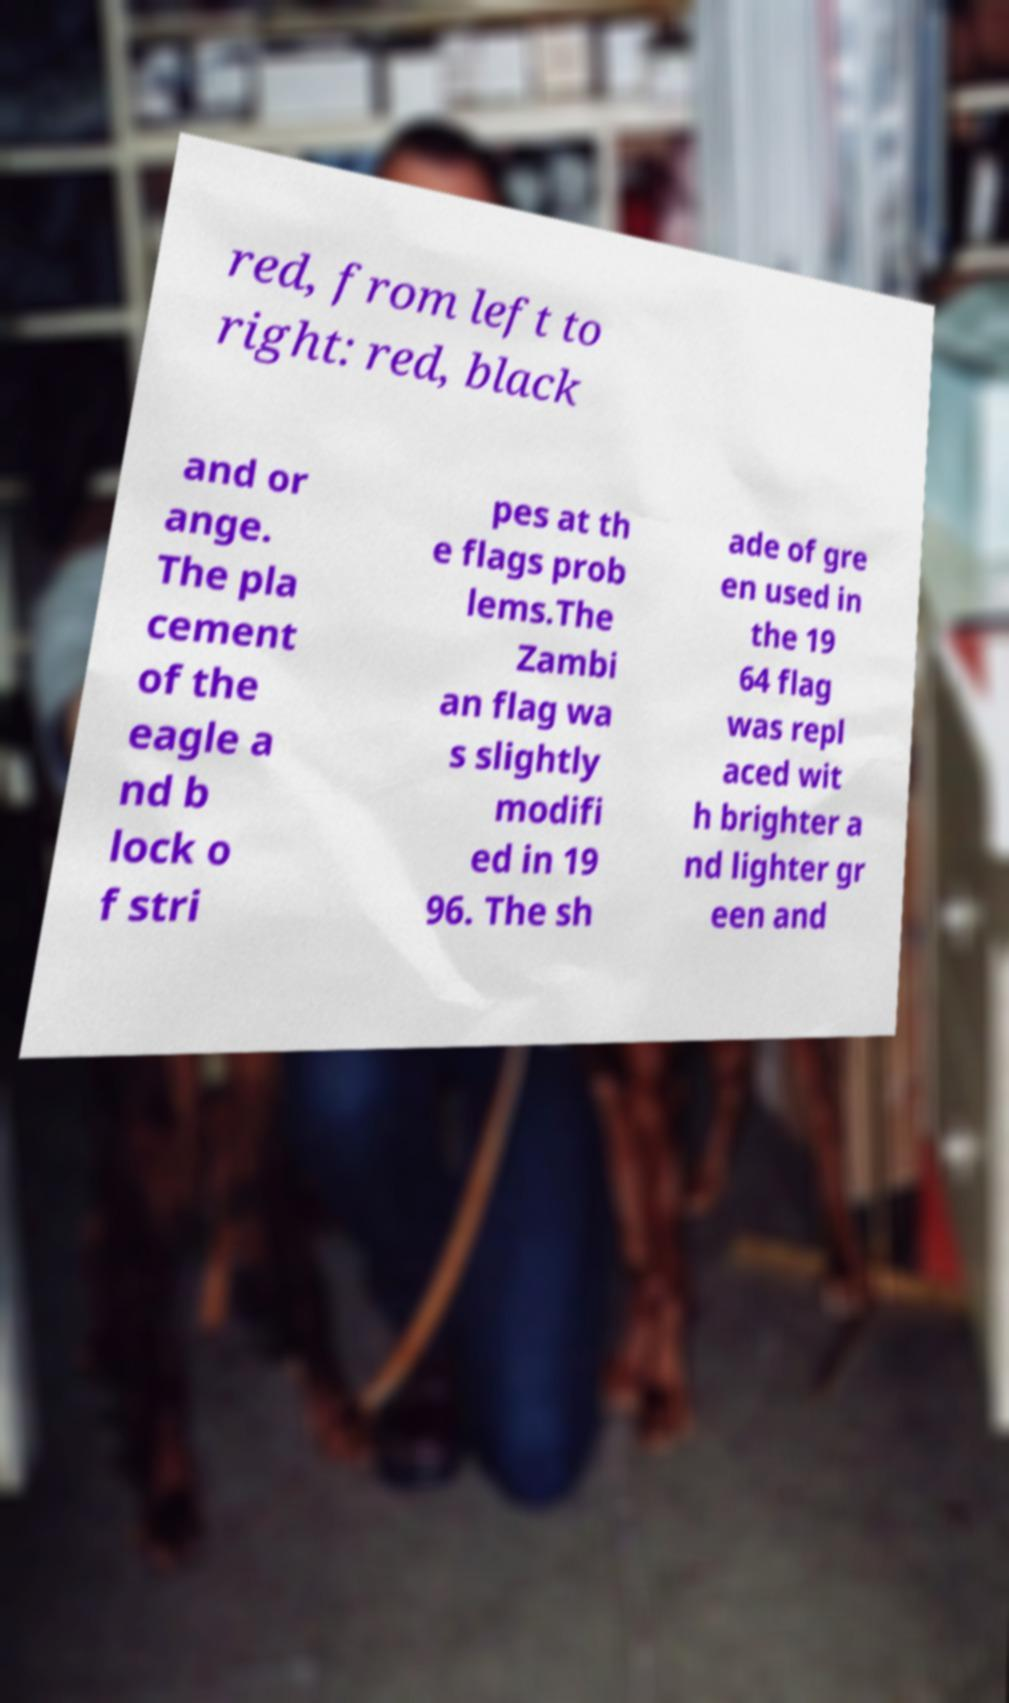Can you accurately transcribe the text from the provided image for me? red, from left to right: red, black and or ange. The pla cement of the eagle a nd b lock o f stri pes at th e flags prob lems.The Zambi an flag wa s slightly modifi ed in 19 96. The sh ade of gre en used in the 19 64 flag was repl aced wit h brighter a nd lighter gr een and 